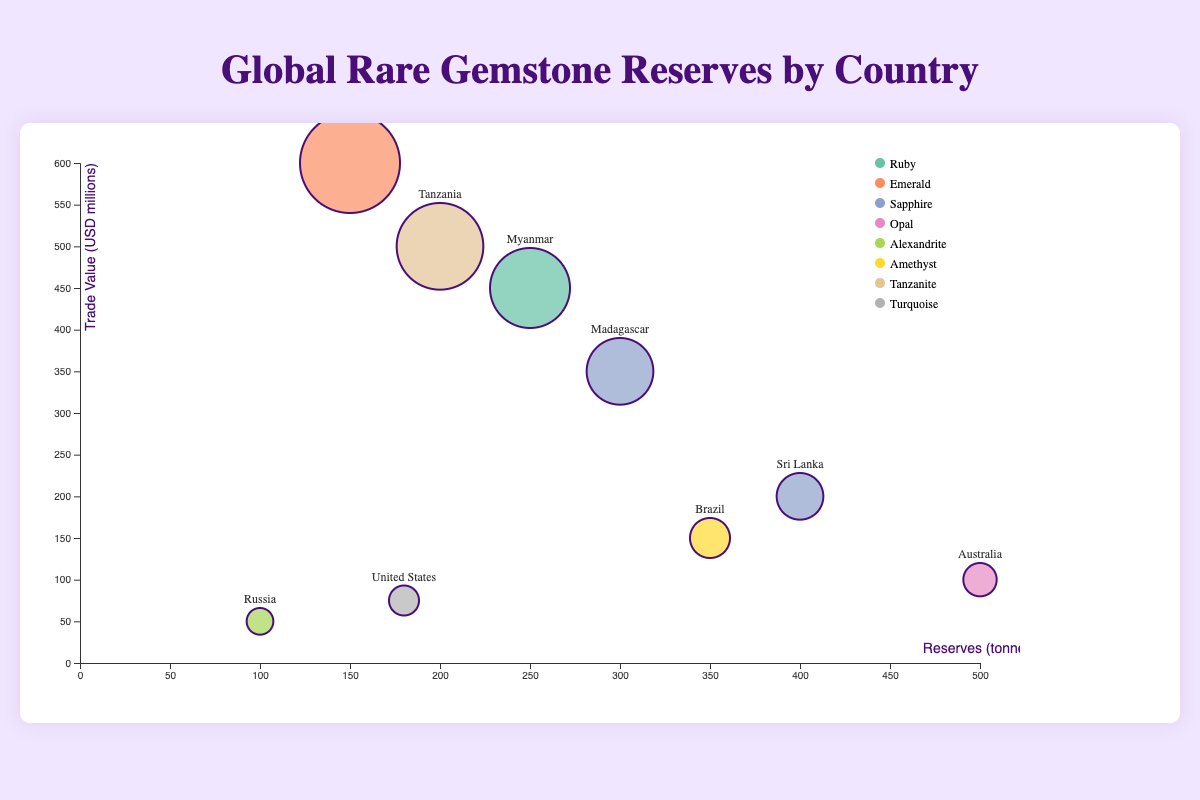What does the x-axis represent in the bubble chart? The x-axis represents the reserves of rare gemstones in tonnes for each country.
Answer: Reserves (tonnes) Which country has the highest trade value for its gemstone? By looking at the y-axis, which shows the trade value, Colombia has the highest trade value at $600 million for its Emerald reserves.
Answer: Colombia How many gemstones have more than 300 tonnes in reserves? The gemstones from Madagascar (Sapphire, 300 tonnes), Australia (Opal, 500 tonnes), Sri Lanka (Sapphire, 400 tonnes), and Brazil (Amethyst, 350 tonnes) all exceed 300 tonnes.
Answer: Four Which countries have Sapphire as their primary gemstone, and how do their trade values compare? The countries with Sapphire as their primary gemstone are Madagascar and Sri Lanka. Madagascar's trade value is $350 million, while Sri Lanka's trade value is $200 million.
Answer: Madagascar: $350 million, Sri Lanka: $200 million What is the correlation between reserves and trade values among the countries listed? By observing the chart, there's no clear linear correlation between reserves and trade values. For example, Australia has the highest reserves (500 tonnes) but a relatively low trade value ($100 million), whereas Colombia has moderate reserves (150 tonnes) but the highest trade value ($600 million).
Answer: No clear linear correlation Which gemstone has the smallest reserve and what is its trade value? The smallest reserve is for Alexandrite in Russia, with 100 tonnes and a trade value of $50 million.
Answer: Alexandrite in Russia, $50 million What is the combined trade value of the gemstones from Colombia and Tanzania? The trade value for Colombia is $600 million, and for Tanzania, it is $500 million. Combined, it totals $600 million + $500 million = $1,100 million.
Answer: $1,100 million Is there any country with a higher trade value than Myanmar but lower reserves? Yes, Tanzania has a higher trade value ($500 million) compared to Myanmar ($450 million) but has lower reserves (200 tonnes vs. 250 tonnes).
Answer: Tanzania Which gemstone from the United States and Russia has a greater trade value, and by how much? The United States has Turquoise with a trade value of $75 million, while Russia has Alexandrite with a trade value of $50 million. Turquoise has a greater trade value by $75 million - $50 million = $25 million.
Answer: Turquoise by $25 million 